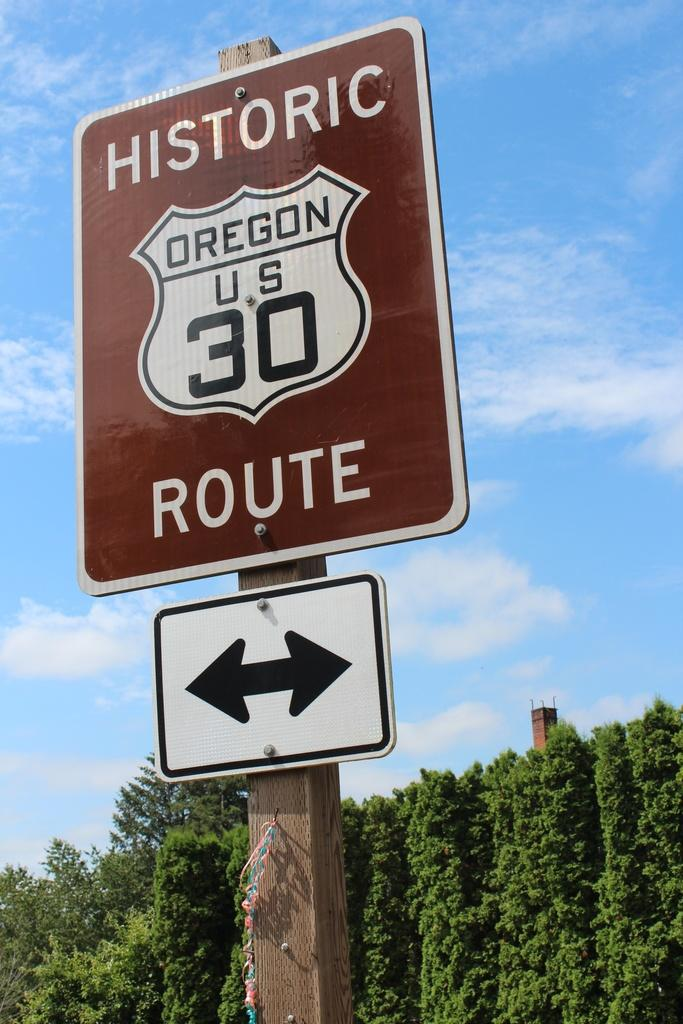<image>
Share a concise interpretation of the image provided. a sign that has the number 30 on it in brown 